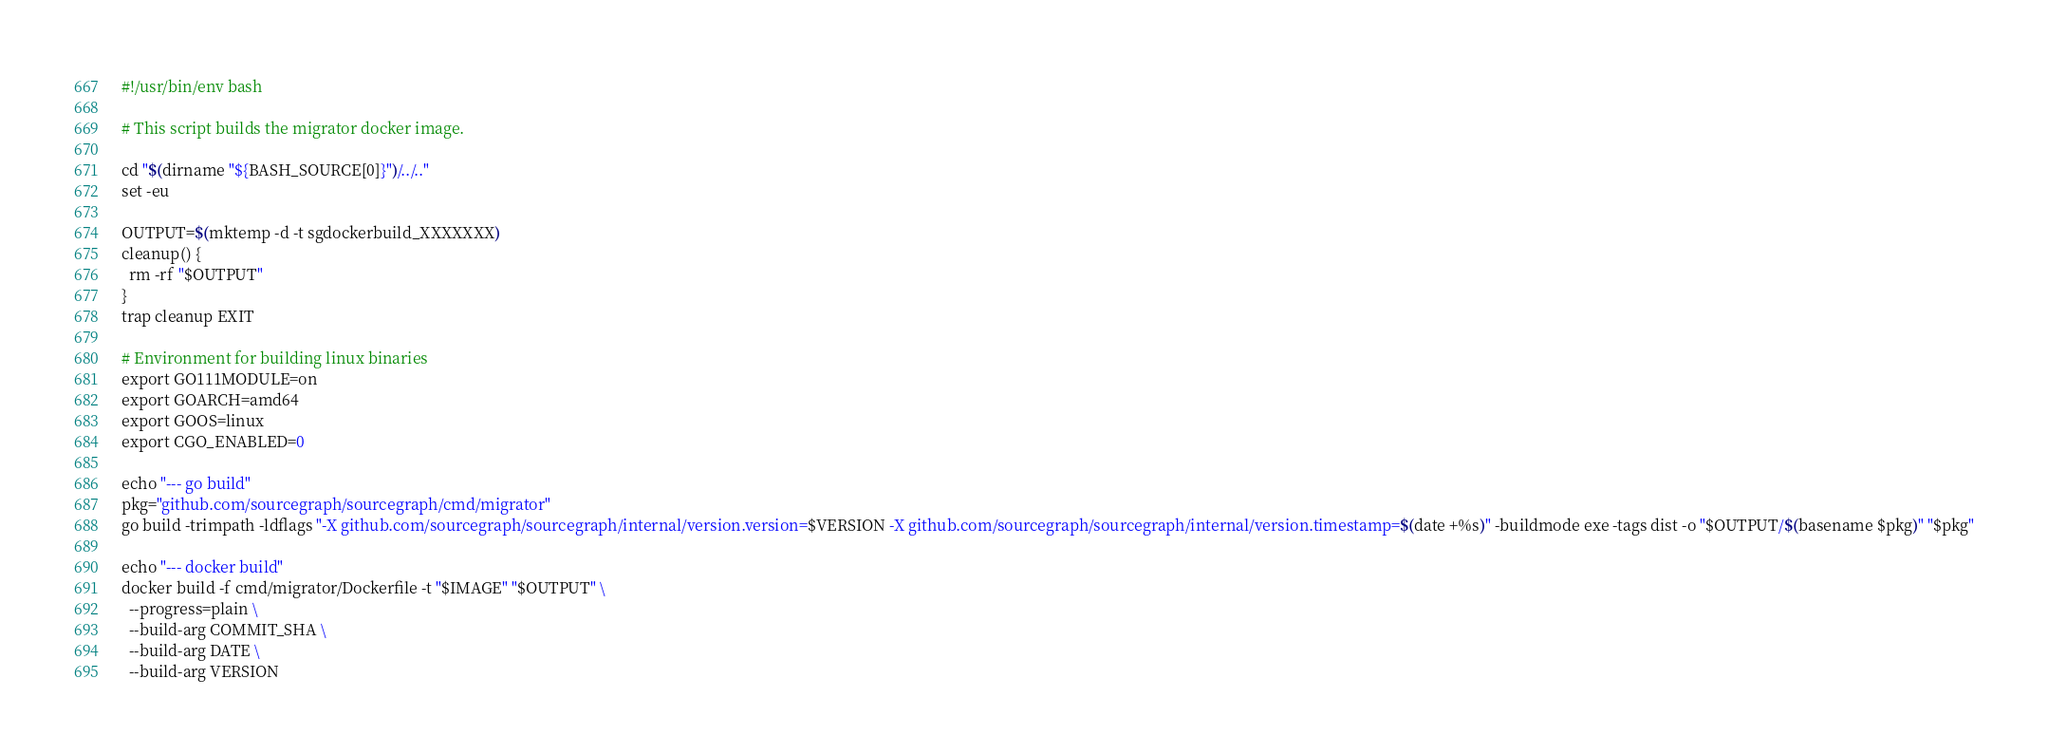<code> <loc_0><loc_0><loc_500><loc_500><_Bash_>#!/usr/bin/env bash

# This script builds the migrator docker image.

cd "$(dirname "${BASH_SOURCE[0]}")/../.."
set -eu

OUTPUT=$(mktemp -d -t sgdockerbuild_XXXXXXX)
cleanup() {
  rm -rf "$OUTPUT"
}
trap cleanup EXIT

# Environment for building linux binaries
export GO111MODULE=on
export GOARCH=amd64
export GOOS=linux
export CGO_ENABLED=0

echo "--- go build"
pkg="github.com/sourcegraph/sourcegraph/cmd/migrator"
go build -trimpath -ldflags "-X github.com/sourcegraph/sourcegraph/internal/version.version=$VERSION -X github.com/sourcegraph/sourcegraph/internal/version.timestamp=$(date +%s)" -buildmode exe -tags dist -o "$OUTPUT/$(basename $pkg)" "$pkg"

echo "--- docker build"
docker build -f cmd/migrator/Dockerfile -t "$IMAGE" "$OUTPUT" \
  --progress=plain \
  --build-arg COMMIT_SHA \
  --build-arg DATE \
  --build-arg VERSION
</code> 